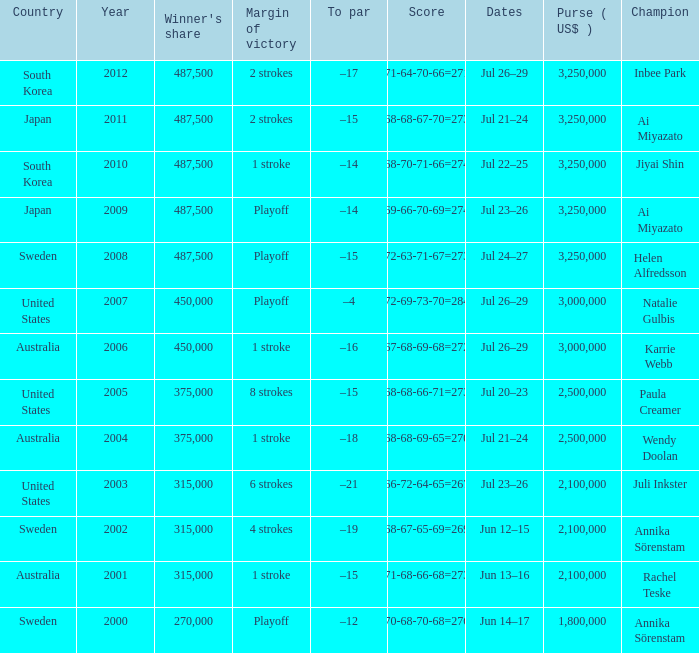Which Country has a Score of 70-68-70-68=276? Sweden. 